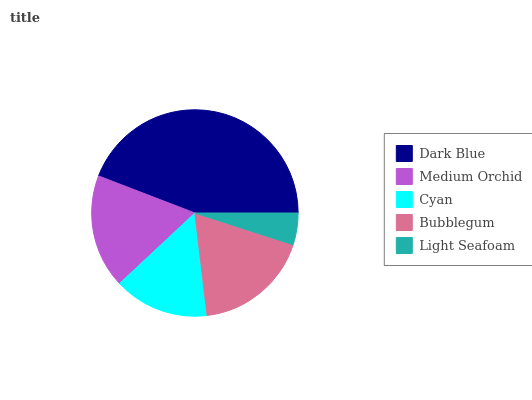Is Light Seafoam the minimum?
Answer yes or no. Yes. Is Dark Blue the maximum?
Answer yes or no. Yes. Is Medium Orchid the minimum?
Answer yes or no. No. Is Medium Orchid the maximum?
Answer yes or no. No. Is Dark Blue greater than Medium Orchid?
Answer yes or no. Yes. Is Medium Orchid less than Dark Blue?
Answer yes or no. Yes. Is Medium Orchid greater than Dark Blue?
Answer yes or no. No. Is Dark Blue less than Medium Orchid?
Answer yes or no. No. Is Medium Orchid the high median?
Answer yes or no. Yes. Is Medium Orchid the low median?
Answer yes or no. Yes. Is Bubblegum the high median?
Answer yes or no. No. Is Light Seafoam the low median?
Answer yes or no. No. 